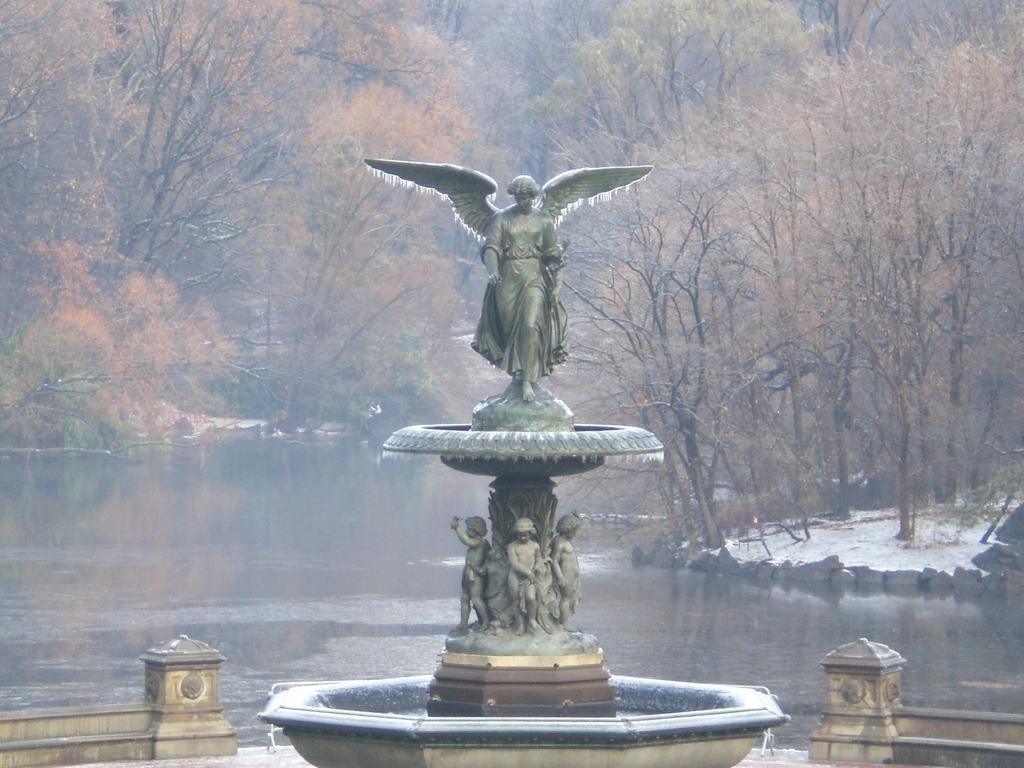What is the main subject in the image? There is a statue in the image. What other features can be seen in the image? A: There is a fountain in the image. What type of structures are present in the image? There are walls in the image. What can be seen in the background of the image? Water, rocks, and trees are visible in the background of the image. What type of room is depicted in the image? There is no room depicted in the image; it features a statue, a fountain, walls, and a background with water, rocks, and trees. 